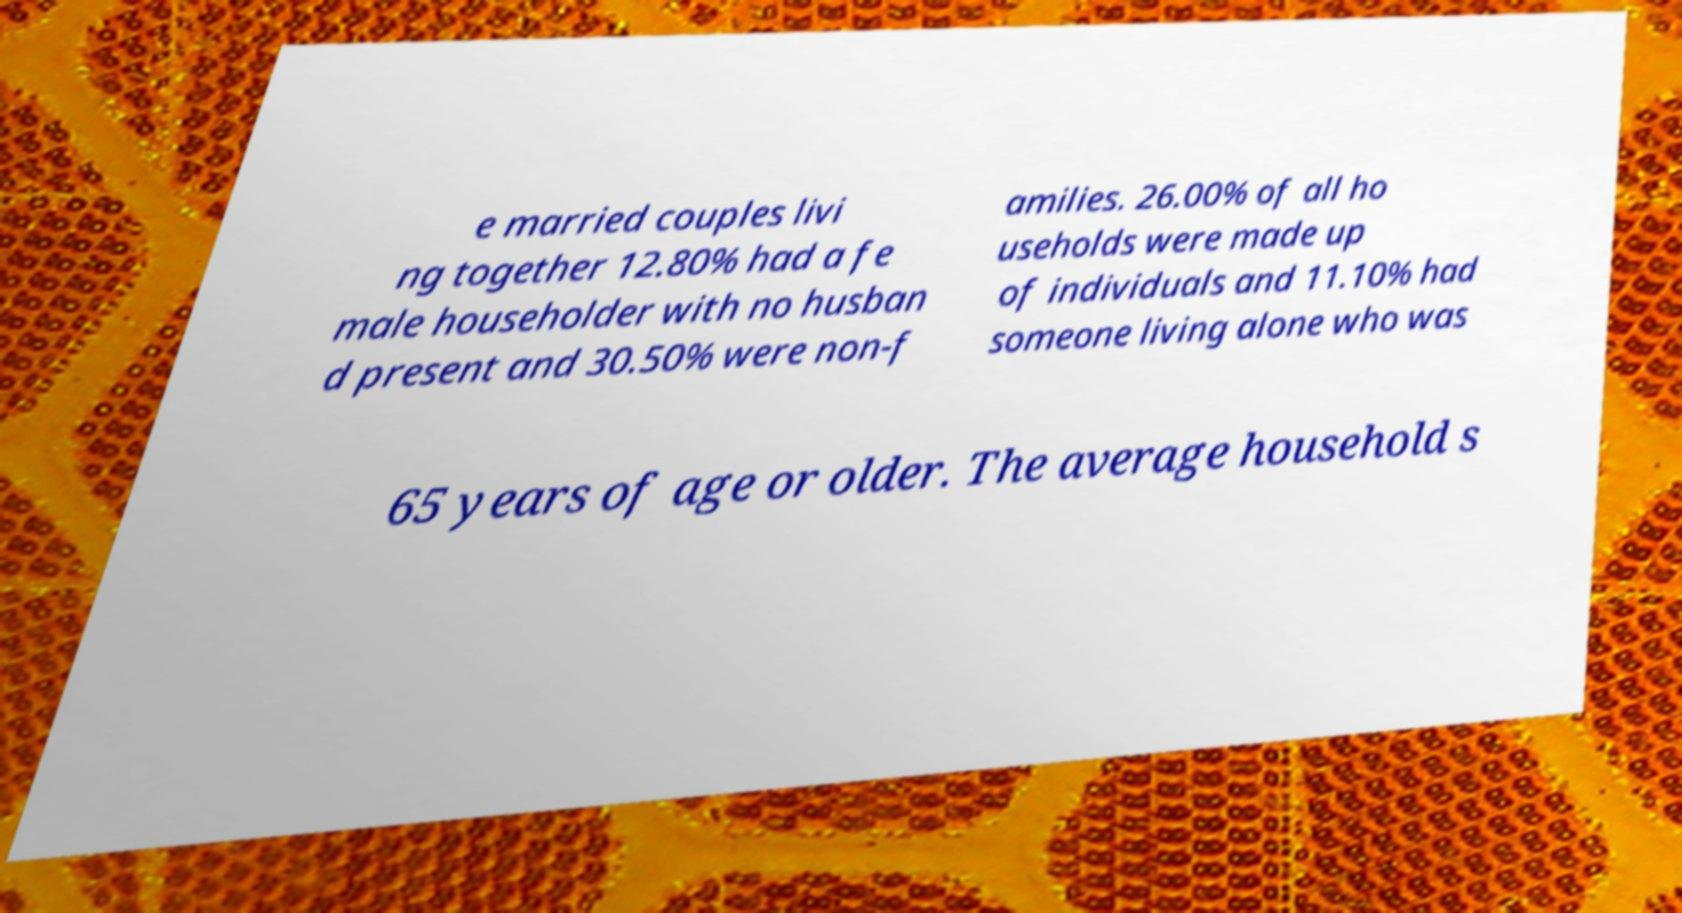Can you read and provide the text displayed in the image?This photo seems to have some interesting text. Can you extract and type it out for me? e married couples livi ng together 12.80% had a fe male householder with no husban d present and 30.50% were non-f amilies. 26.00% of all ho useholds were made up of individuals and 11.10% had someone living alone who was 65 years of age or older. The average household s 